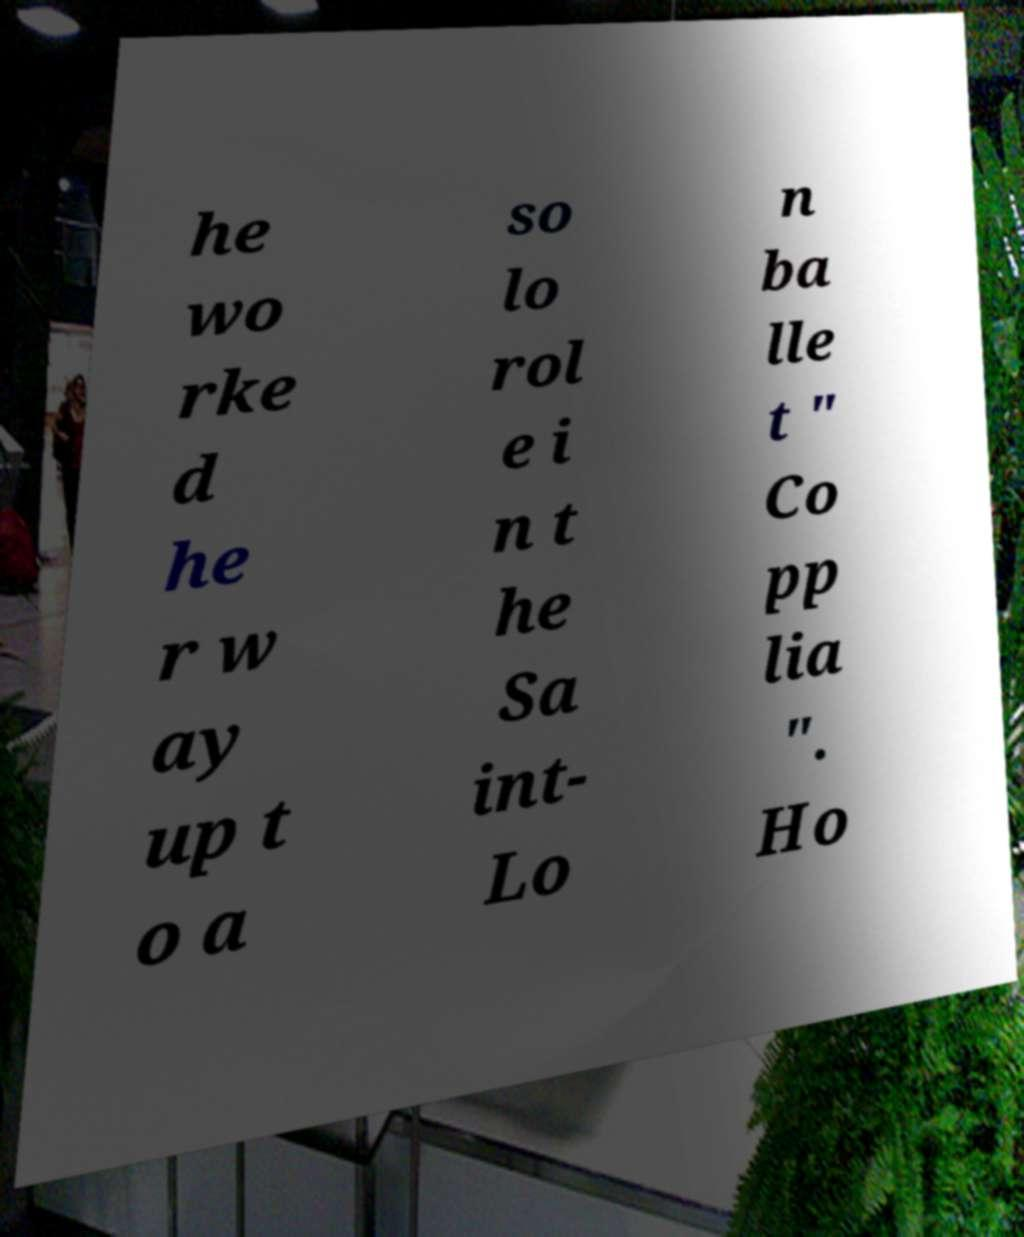I need the written content from this picture converted into text. Can you do that? he wo rke d he r w ay up t o a so lo rol e i n t he Sa int- Lo n ba lle t " Co pp lia ". Ho 